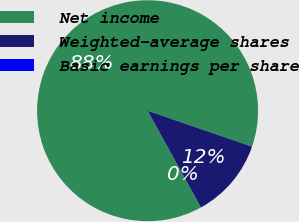Convert chart. <chart><loc_0><loc_0><loc_500><loc_500><pie_chart><fcel>Net income<fcel>Weighted-average shares<fcel>Basic earnings per share<nl><fcel>88.3%<fcel>11.7%<fcel>0.0%<nl></chart> 